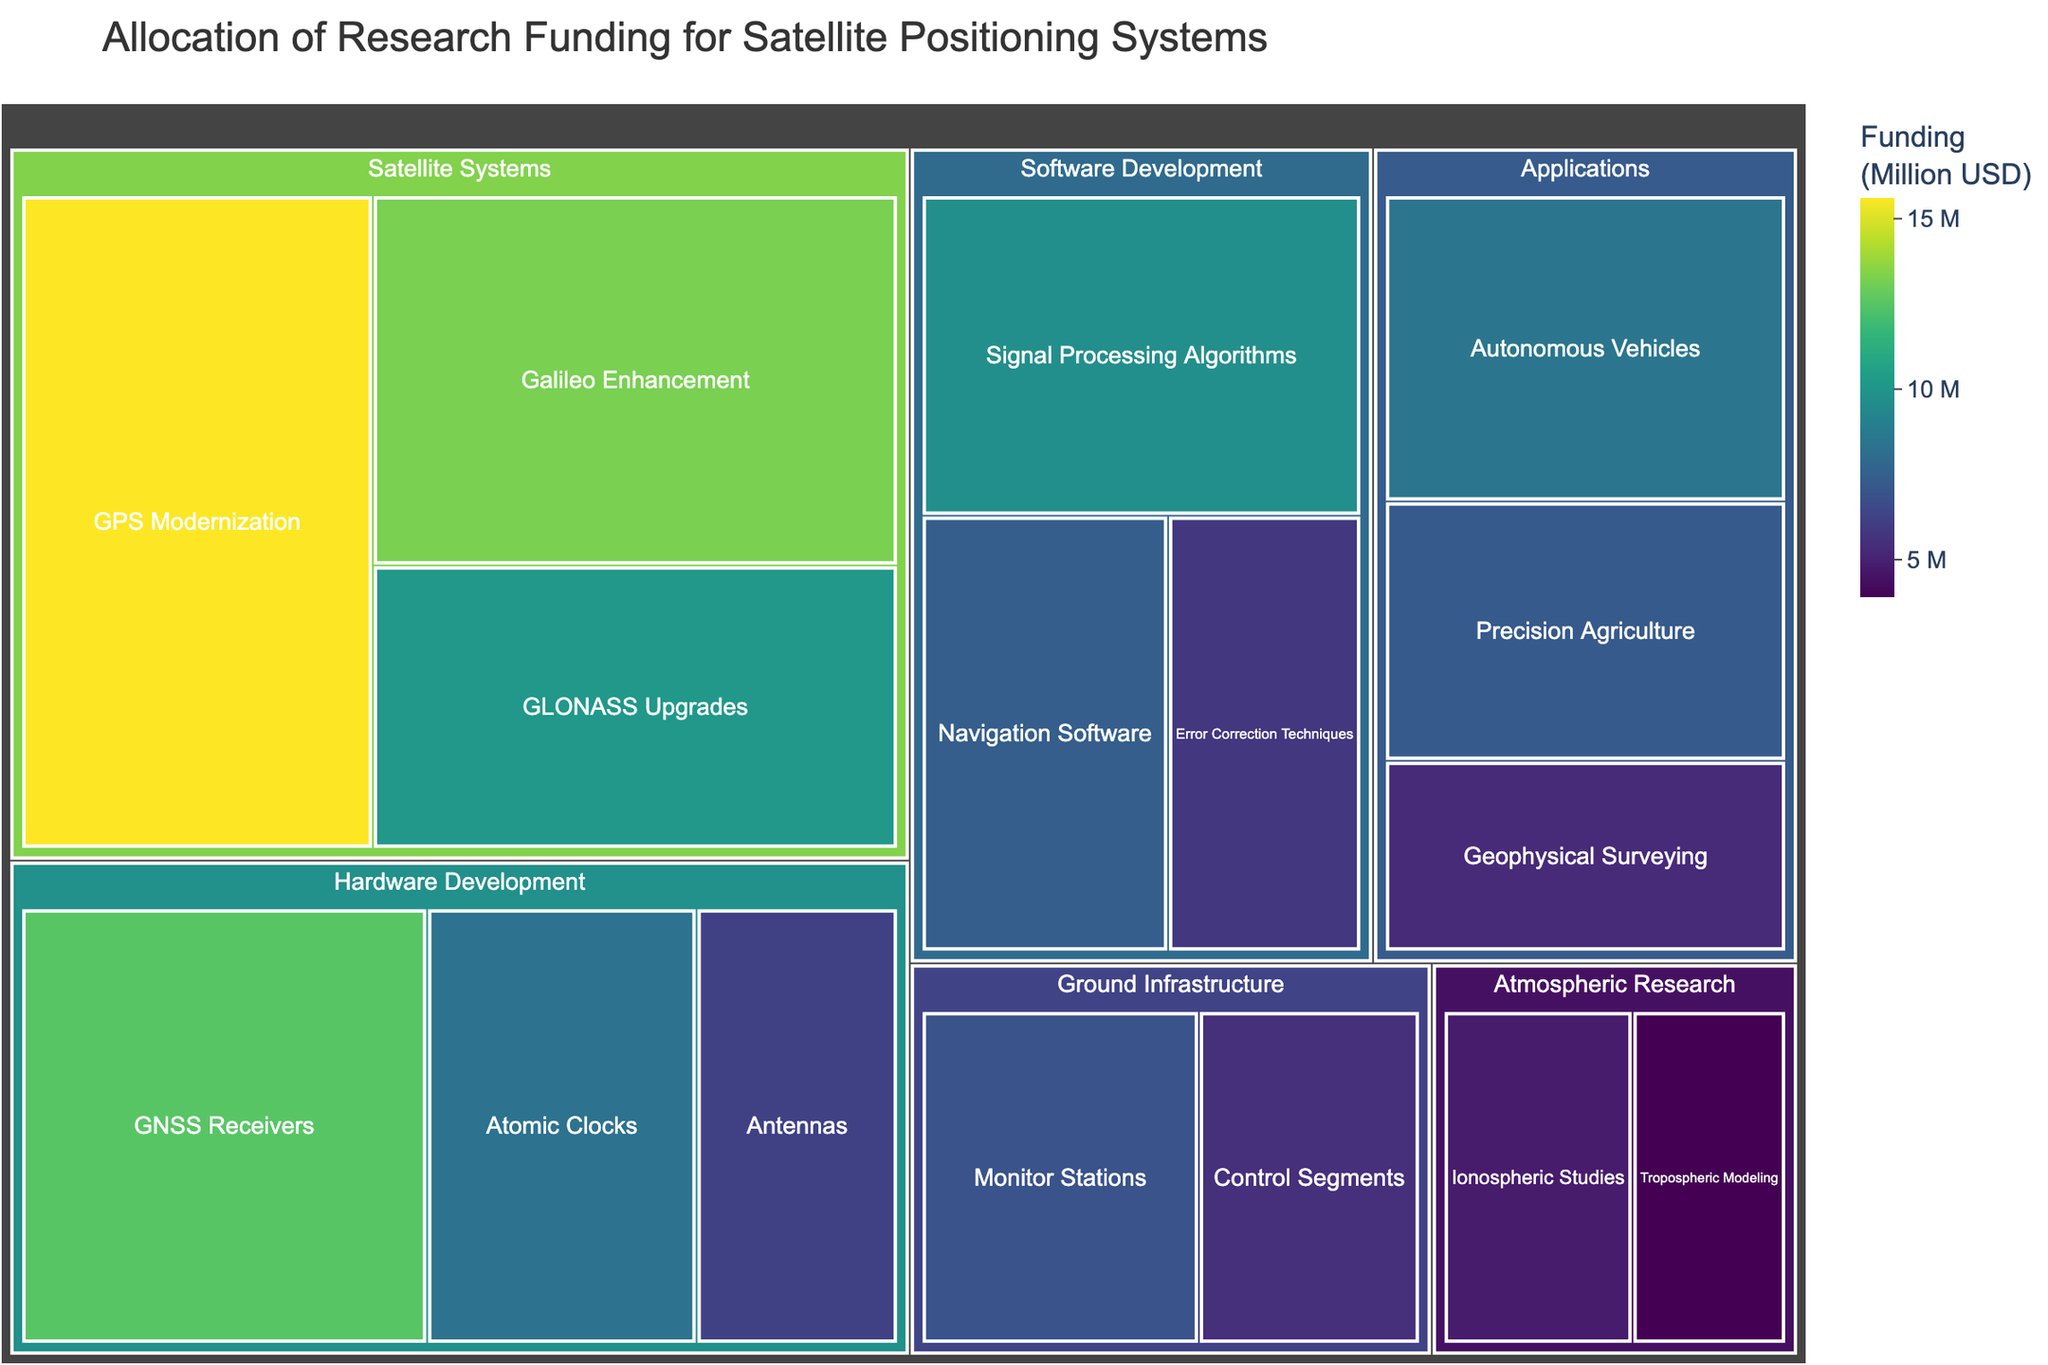What's the largest funding category in the treemap? Look for the category with the largest allocation, which is indicated by the size of the box. According to the data, 'Satellite Systems' has the largest funding.
Answer: Satellite Systems Which subcategory within 'Hardware Development' received the most funding? Evaluate the subcategories under 'Hardware Development' and compare their allocations. 'GNSS Receivers' has the highest funding.
Answer: GNSS Receivers What's the total funding allocated to the 'Applications' category? Sum the funding for all subcategories under 'Applications': Precision Agriculture (7.2) + Autonomous Vehicles (8.5) + Geophysical Surveying (5.3). 7.2 + 8.5 + 5.3 = 21.0.
Answer: 21.0 Million USD Which category has fewer funds allocated than 'Signal Processing Algorithms' within 'Software Development'? Compare the funding of 'Signal Processing Algorithms' (9.7) to other categories. 'Ground Infrastructure', 'Atmospheric Research', and 'Applications' each have individual subcategories with less funding than 9.7 million USD.
Answer: Ground Infrastructure, Atmospheric Research, Applications Arrange the following subcategories in descending order of their funding: 'Atomic Clocks', 'Galileo Enhancement', 'Monitor Stations'. Compare the funding amounts for these subcategories: Atomic Clocks (8.3), Galileo Enhancement (13.2), Monitor Stations (6.9). The descending order is Galileo Enhancement > Atomic Clocks > Monitor Stations.
Answer: Galileo Enhancement, Atomic Clocks, Monitor Stations Which is higher: the combined funding for 'Hardware Development' or 'Software Development' categories? Sum the funding for each category. 'Hardware Development': 12.5 + 8.3 + 6.2 = 27.0, 'Software Development': 9.7 + 7.4 + 5.8 = 22.9. Compare the two sums to determine which is higher.
Answer: Hardware Development What’s the percentage of total funding allocated to 'GPS Modernization' within 'Satellite Systems'? Calculate the percentage by taking the funding for GPS Modernization (15.6) divided by the total funding for Satellite Systems (15.6 + 13.2 + 10.1 = 38.9) then multiply by 100. (15.6 / 38.9) * 100 ≈ 40.1%.
Answer: 40.1% Is there any subcategory with funding just under 6 million USD? Review the funding values to find any close to but under 6 million USD. 'Error Correction Techniques' has 5.8 million USD.
Answer: Error Correction Techniques List two subcategories within 'Satellite Systems' in increasing order of funding. Compare the funding amounts under 'Satellite Systems': GPS Modernization (15.6), Galileo Enhancement (13.2), and GLONASS Upgrades (10.1). The increasing order is GLONASS Upgrades, Galileo Enhancement.
Answer: GLONASS Upgrades, Galileo Enhancement 